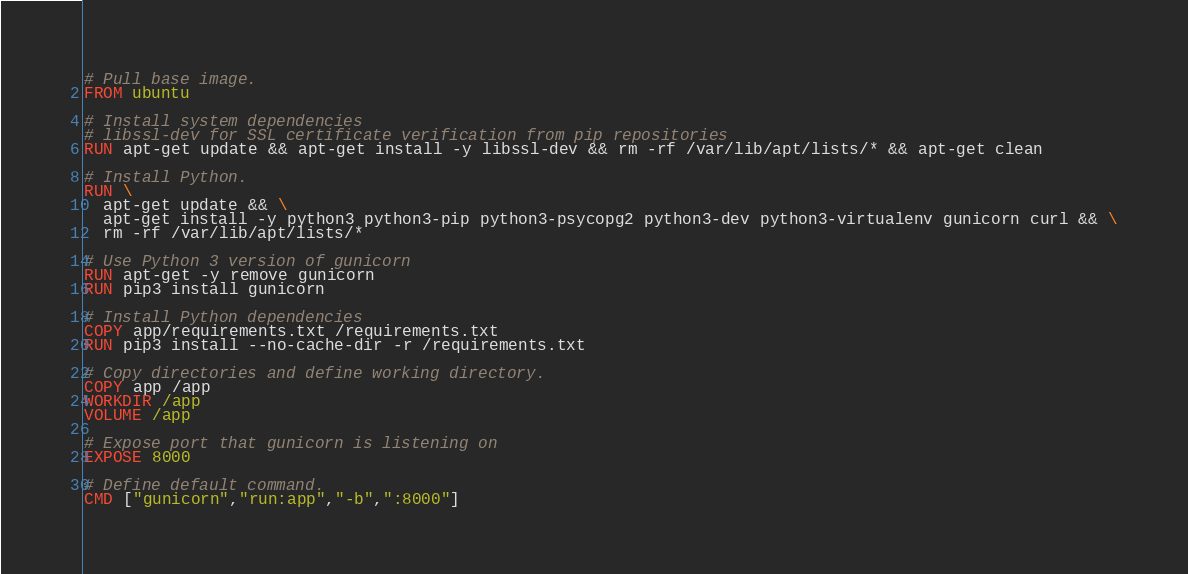Convert code to text. <code><loc_0><loc_0><loc_500><loc_500><_Dockerfile_># Pull base image.
FROM ubuntu

# Install system dependencies
# libssl-dev for SSL certificate verification from pip repositories
RUN apt-get update && apt-get install -y libssl-dev && rm -rf /var/lib/apt/lists/* && apt-get clean

# Install Python.
RUN \
  apt-get update && \
  apt-get install -y python3 python3-pip python3-psycopg2 python3-dev python3-virtualenv gunicorn curl && \
  rm -rf /var/lib/apt/lists/*

# Use Python 3 version of gunicorn
RUN apt-get -y remove gunicorn
RUN pip3 install gunicorn

# Install Python dependencies
COPY app/requirements.txt /requirements.txt
RUN pip3 install --no-cache-dir -r /requirements.txt

# Copy directories and define working directory.
COPY app /app
WORKDIR /app
VOLUME /app

# Expose port that gunicorn is listening on
EXPOSE 8000

# Define default command.
CMD ["gunicorn","run:app","-b",":8000"]
</code> 